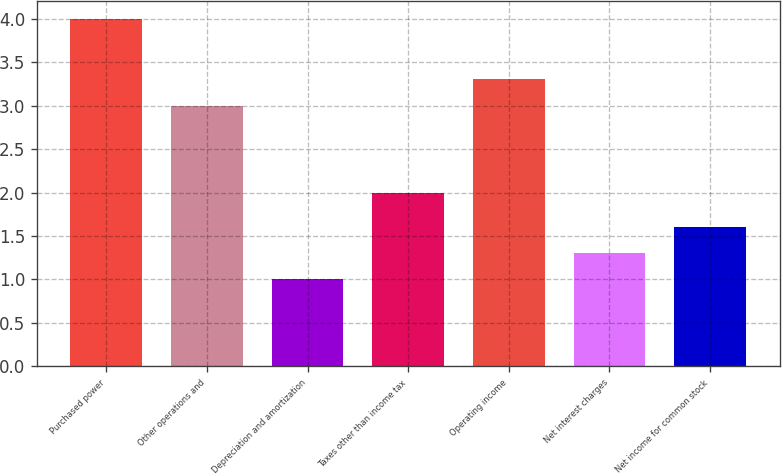Convert chart to OTSL. <chart><loc_0><loc_0><loc_500><loc_500><bar_chart><fcel>Purchased power<fcel>Other operations and<fcel>Depreciation and amortization<fcel>Taxes other than income tax<fcel>Operating income<fcel>Net interest charges<fcel>Net income for common stock<nl><fcel>4<fcel>3<fcel>1<fcel>2<fcel>3.3<fcel>1.3<fcel>1.6<nl></chart> 